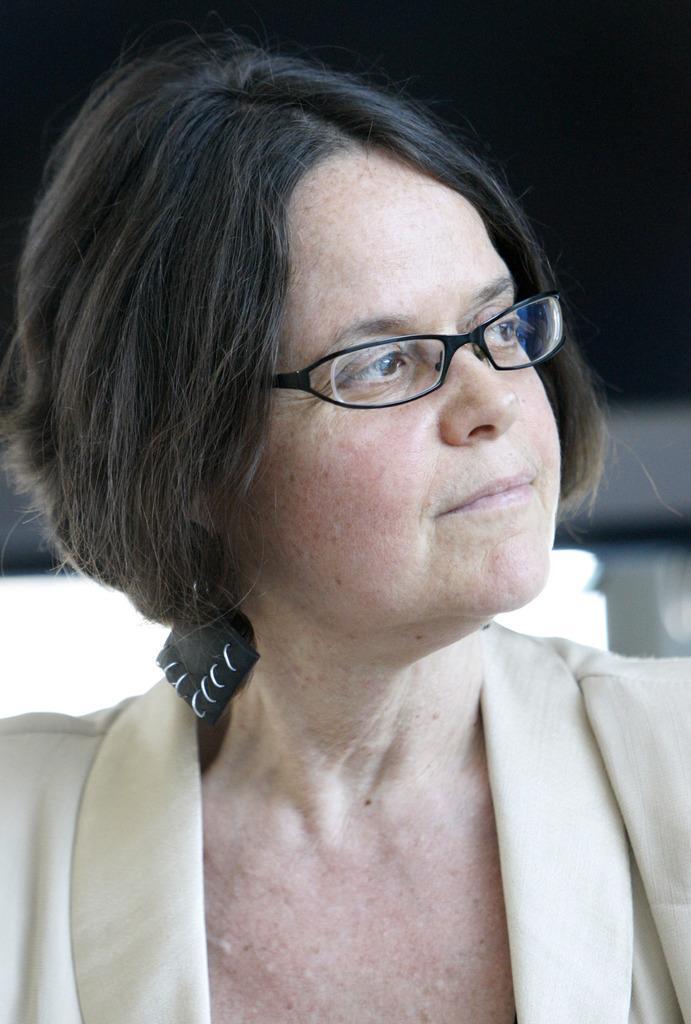Can you describe this image briefly? In this image in the front there is a woman wearing specs and the background is blurry. 